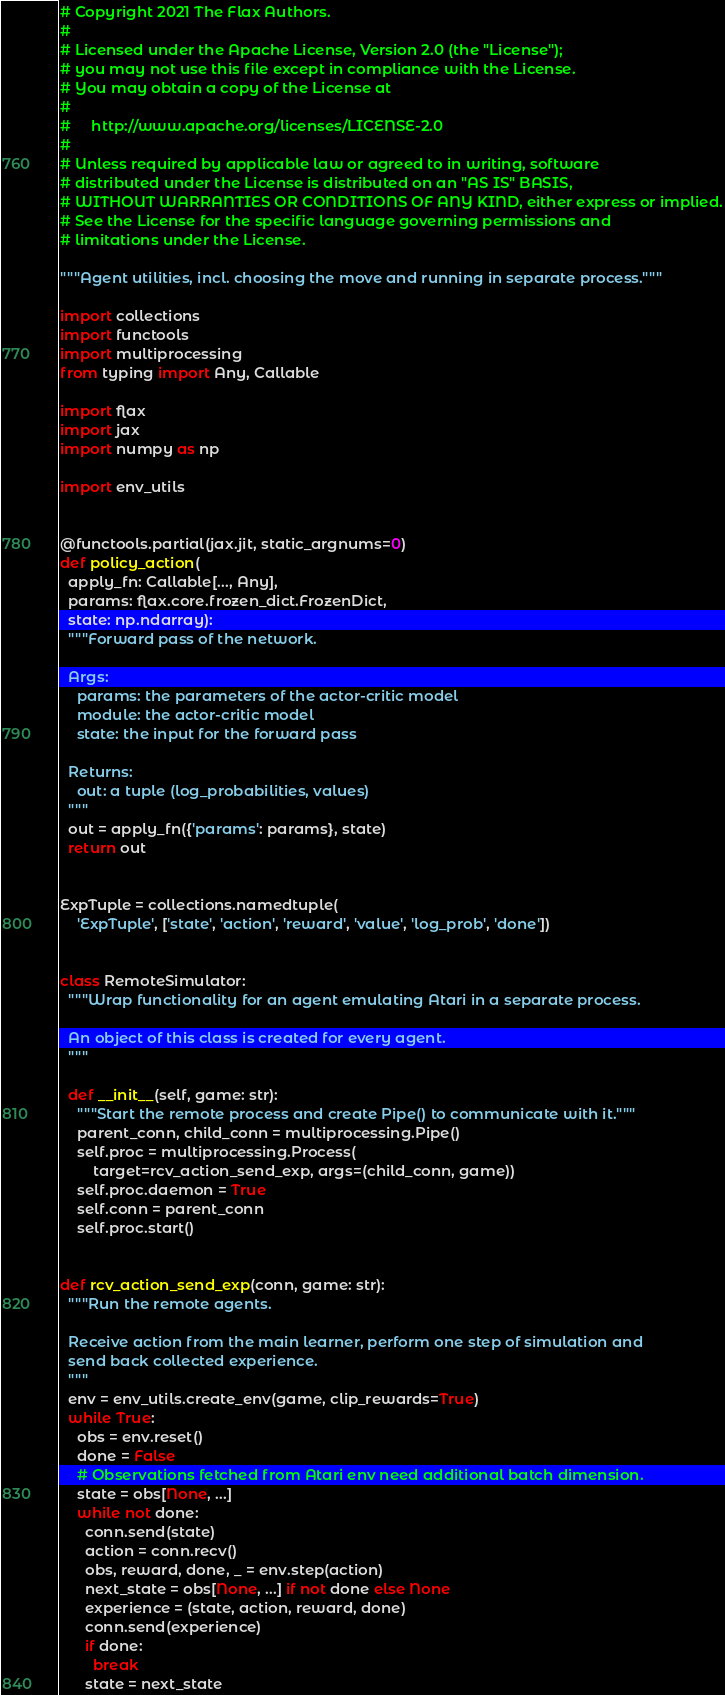<code> <loc_0><loc_0><loc_500><loc_500><_Python_># Copyright 2021 The Flax Authors.
#
# Licensed under the Apache License, Version 2.0 (the "License");
# you may not use this file except in compliance with the License.
# You may obtain a copy of the License at
#
#     http://www.apache.org/licenses/LICENSE-2.0
#
# Unless required by applicable law or agreed to in writing, software
# distributed under the License is distributed on an "AS IS" BASIS,
# WITHOUT WARRANTIES OR CONDITIONS OF ANY KIND, either express or implied.
# See the License for the specific language governing permissions and
# limitations under the License.

"""Agent utilities, incl. choosing the move and running in separate process."""

import collections
import functools
import multiprocessing
from typing import Any, Callable

import flax
import jax
import numpy as np

import env_utils


@functools.partial(jax.jit, static_argnums=0)
def policy_action(
  apply_fn: Callable[..., Any],
  params: flax.core.frozen_dict.FrozenDict,
  state: np.ndarray):
  """Forward pass of the network.

  Args:
    params: the parameters of the actor-critic model
    module: the actor-critic model
    state: the input for the forward pass

  Returns:
    out: a tuple (log_probabilities, values)
  """
  out = apply_fn({'params': params}, state)
  return out


ExpTuple = collections.namedtuple(
    'ExpTuple', ['state', 'action', 'reward', 'value', 'log_prob', 'done'])


class RemoteSimulator:
  """Wrap functionality for an agent emulating Atari in a separate process.

  An object of this class is created for every agent.
  """

  def __init__(self, game: str):
    """Start the remote process and create Pipe() to communicate with it."""
    parent_conn, child_conn = multiprocessing.Pipe()
    self.proc = multiprocessing.Process(
        target=rcv_action_send_exp, args=(child_conn, game))
    self.proc.daemon = True
    self.conn = parent_conn
    self.proc.start()


def rcv_action_send_exp(conn, game: str):
  """Run the remote agents.

  Receive action from the main learner, perform one step of simulation and
  send back collected experience.
  """
  env = env_utils.create_env(game, clip_rewards=True)
  while True:
    obs = env.reset()
    done = False
    # Observations fetched from Atari env need additional batch dimension.
    state = obs[None, ...]
    while not done:
      conn.send(state)
      action = conn.recv()
      obs, reward, done, _ = env.step(action)
      next_state = obs[None, ...] if not done else None
      experience = (state, action, reward, done)
      conn.send(experience)
      if done:
        break
      state = next_state
</code> 